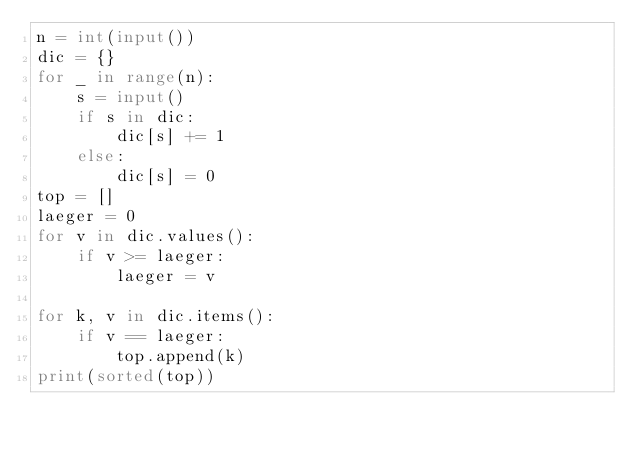<code> <loc_0><loc_0><loc_500><loc_500><_Python_>n = int(input())
dic = {}
for _ in range(n):
    s = input()
    if s in dic:
        dic[s] += 1
    else:
        dic[s] = 0
top = []
laeger = 0
for v in dic.values():
    if v >= laeger:
        laeger = v

for k, v in dic.items():
    if v == laeger:
        top.append(k)
print(sorted(top))
</code> 